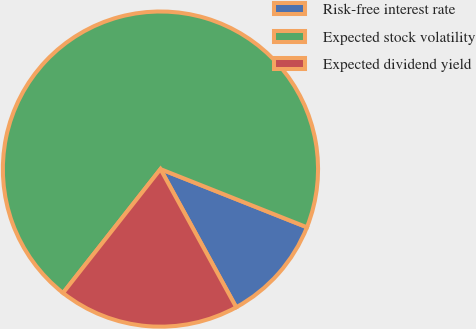Convert chart. <chart><loc_0><loc_0><loc_500><loc_500><pie_chart><fcel>Risk-free interest rate<fcel>Expected stock volatility<fcel>Expected dividend yield<nl><fcel>11.0%<fcel>70.41%<fcel>18.59%<nl></chart> 